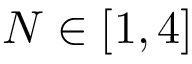<formula> <loc_0><loc_0><loc_500><loc_500>N \in [ 1 , 4 ]</formula> 